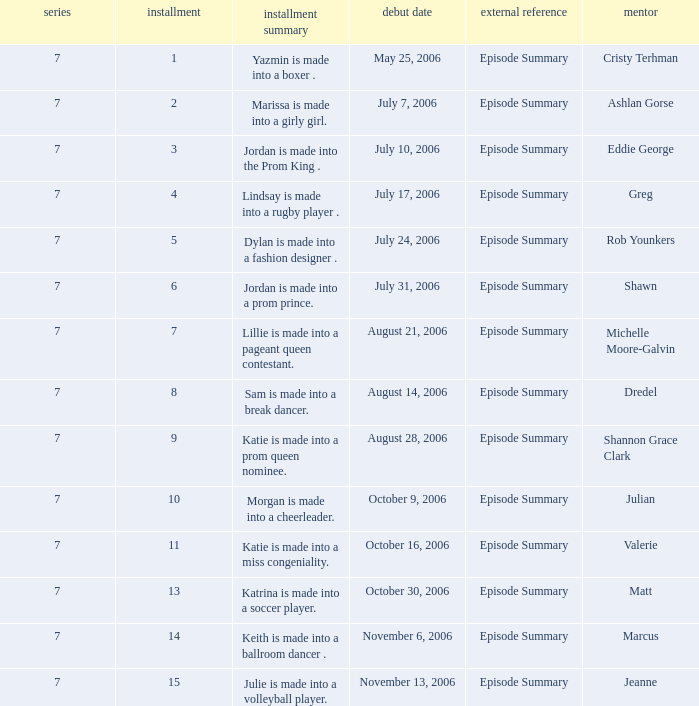What the summary of episode 15? Julie is made into a volleyball player. 